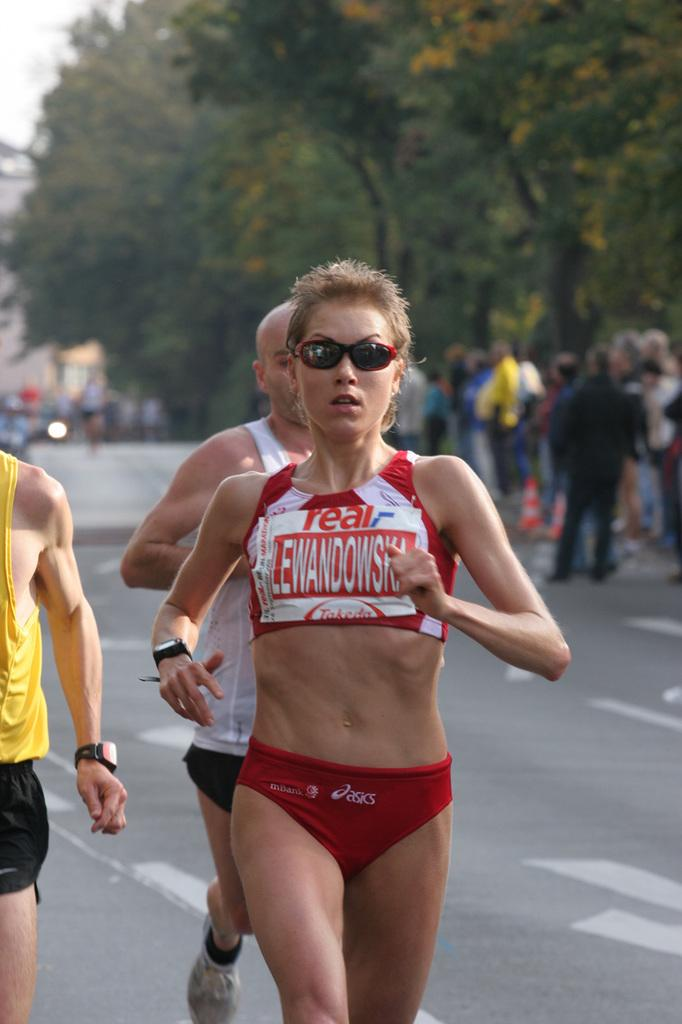<image>
Share a concise interpretation of the image provided. a runner in a race wears a bib reading Lewandowska 